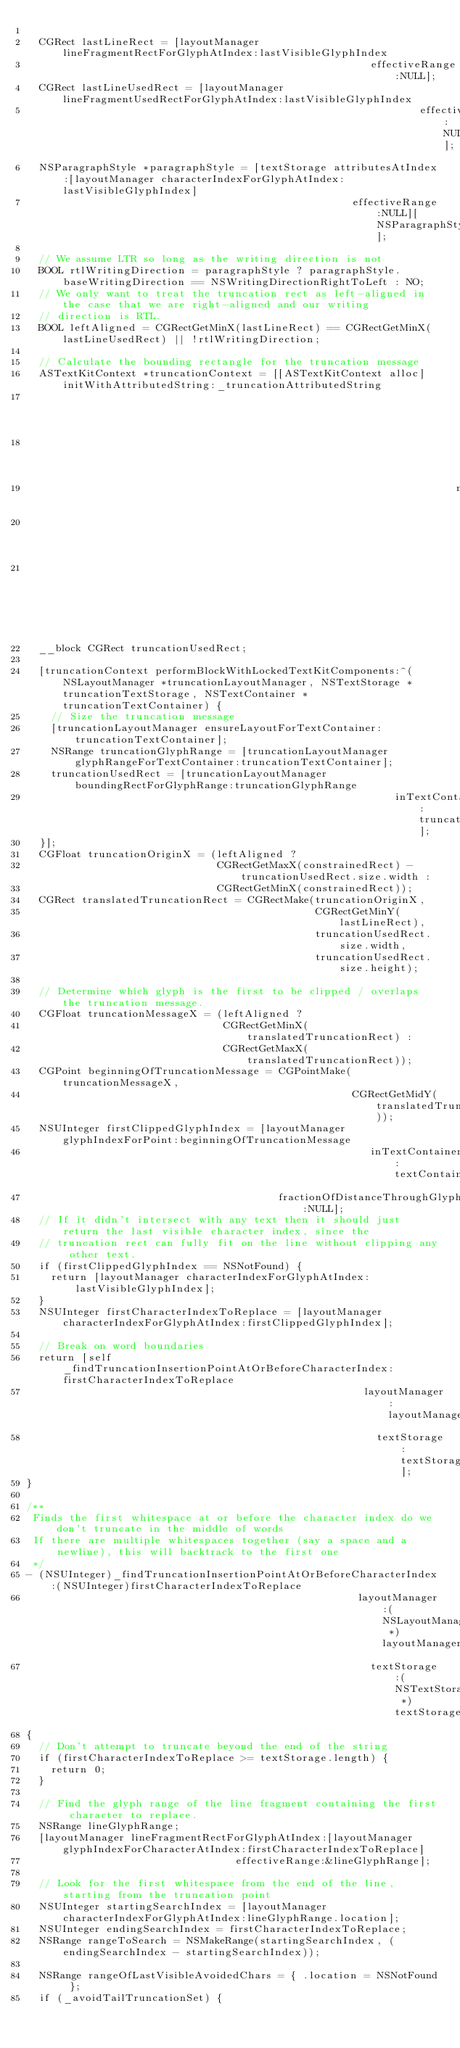Convert code to text. <code><loc_0><loc_0><loc_500><loc_500><_ObjectiveC_>
  CGRect lastLineRect = [layoutManager lineFragmentRectForGlyphAtIndex:lastVisibleGlyphIndex
                                                        effectiveRange:NULL];
  CGRect lastLineUsedRect = [layoutManager lineFragmentUsedRectForGlyphAtIndex:lastVisibleGlyphIndex
                                                                effectiveRange:NULL];
  NSParagraphStyle *paragraphStyle = [textStorage attributesAtIndex:[layoutManager characterIndexForGlyphAtIndex:lastVisibleGlyphIndex]
                                                     effectiveRange:NULL][NSParagraphStyleAttributeName];
  
  // We assume LTR so long as the writing direction is not
  BOOL rtlWritingDirection = paragraphStyle ? paragraphStyle.baseWritingDirection == NSWritingDirectionRightToLeft : NO;
  // We only want to treat the truncation rect as left-aligned in the case that we are right-aligned and our writing
  // direction is RTL.
  BOOL leftAligned = CGRectGetMinX(lastLineRect) == CGRectGetMinX(lastLineUsedRect) || !rtlWritingDirection;

  // Calculate the bounding rectangle for the truncation message
  ASTextKitContext *truncationContext = [[ASTextKitContext alloc] initWithAttributedString:_truncationAttributedString
                                                                                 tintColor:nil
                                                                             lineBreakMode:NSLineBreakByWordWrapping
                                                                      maximumNumberOfLines:1
                                                                            exclusionPaths:nil
                                                                           constrainedSize:constrainedRect.size];
  __block CGRect truncationUsedRect;

  [truncationContext performBlockWithLockedTextKitComponents:^(NSLayoutManager *truncationLayoutManager, NSTextStorage *truncationTextStorage, NSTextContainer *truncationTextContainer) {
    // Size the truncation message
    [truncationLayoutManager ensureLayoutForTextContainer:truncationTextContainer];
    NSRange truncationGlyphRange = [truncationLayoutManager glyphRangeForTextContainer:truncationTextContainer];
    truncationUsedRect = [truncationLayoutManager boundingRectForGlyphRange:truncationGlyphRange
                                                            inTextContainer:truncationTextContainer];
  }];
  CGFloat truncationOriginX = (leftAligned ?
                               CGRectGetMaxX(constrainedRect) - truncationUsedRect.size.width :
                               CGRectGetMinX(constrainedRect));
  CGRect translatedTruncationRect = CGRectMake(truncationOriginX,
                                               CGRectGetMinY(lastLineRect),
                                               truncationUsedRect.size.width,
                                               truncationUsedRect.size.height);

  // Determine which glyph is the first to be clipped / overlaps the truncation message.
  CGFloat truncationMessageX = (leftAligned ?
                                CGRectGetMinX(translatedTruncationRect) :
                                CGRectGetMaxX(translatedTruncationRect));
  CGPoint beginningOfTruncationMessage = CGPointMake(truncationMessageX,
                                                     CGRectGetMidY(translatedTruncationRect));
  NSUInteger firstClippedGlyphIndex = [layoutManager glyphIndexForPoint:beginningOfTruncationMessage
                                                        inTextContainer:textContainer
                                         fractionOfDistanceThroughGlyph:NULL];
  // If it didn't intersect with any text then it should just return the last visible character index, since the
  // truncation rect can fully fit on the line without clipping any other text.
  if (firstClippedGlyphIndex == NSNotFound) {
    return [layoutManager characterIndexForGlyphAtIndex:lastVisibleGlyphIndex];
  }
  NSUInteger firstCharacterIndexToReplace = [layoutManager characterIndexForGlyphAtIndex:firstClippedGlyphIndex];

  // Break on word boundaries
  return [self _findTruncationInsertionPointAtOrBeforeCharacterIndex:firstCharacterIndexToReplace
                                                       layoutManager:layoutManager
                                                         textStorage:textStorage];
}

/**
 Finds the first whitespace at or before the character index do we don't truncate in the middle of words
 If there are multiple whitespaces together (say a space and a newline), this will backtrack to the first one
 */
- (NSUInteger)_findTruncationInsertionPointAtOrBeforeCharacterIndex:(NSUInteger)firstCharacterIndexToReplace
                                                      layoutManager:(NSLayoutManager *)layoutManager
                                                        textStorage:(NSTextStorage *)textStorage
{
  // Don't attempt to truncate beyond the end of the string
  if (firstCharacterIndexToReplace >= textStorage.length) {
    return 0;
  }

  // Find the glyph range of the line fragment containing the first character to replace.
  NSRange lineGlyphRange;
  [layoutManager lineFragmentRectForGlyphAtIndex:[layoutManager glyphIndexForCharacterAtIndex:firstCharacterIndexToReplace]
                                  effectiveRange:&lineGlyphRange];

  // Look for the first whitespace from the end of the line, starting from the truncation point
  NSUInteger startingSearchIndex = [layoutManager characterIndexForGlyphAtIndex:lineGlyphRange.location];
  NSUInteger endingSearchIndex = firstCharacterIndexToReplace;
  NSRange rangeToSearch = NSMakeRange(startingSearchIndex, (endingSearchIndex - startingSearchIndex));

  NSRange rangeOfLastVisibleAvoidedChars = { .location = NSNotFound };
  if (_avoidTailTruncationSet) {</code> 